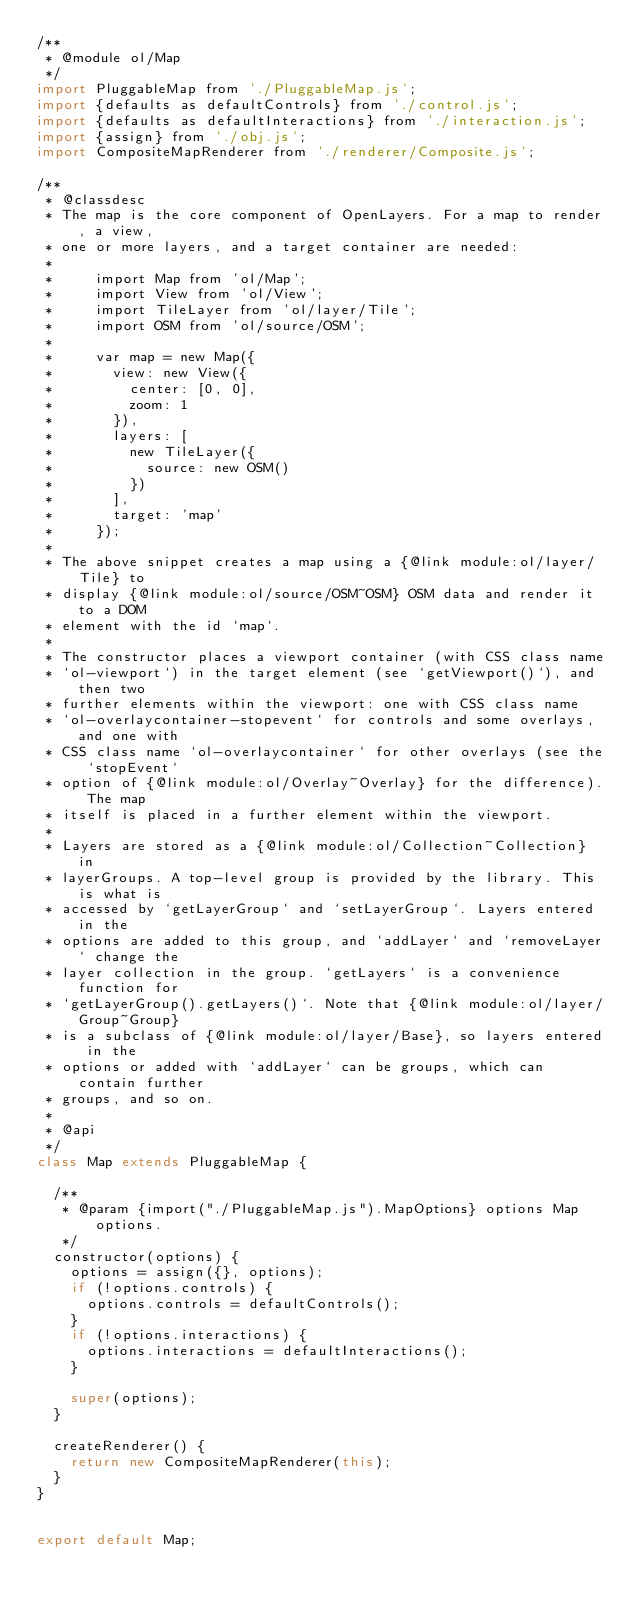Convert code to text. <code><loc_0><loc_0><loc_500><loc_500><_JavaScript_>/**
 * @module ol/Map
 */
import PluggableMap from './PluggableMap.js';
import {defaults as defaultControls} from './control.js';
import {defaults as defaultInteractions} from './interaction.js';
import {assign} from './obj.js';
import CompositeMapRenderer from './renderer/Composite.js';

/**
 * @classdesc
 * The map is the core component of OpenLayers. For a map to render, a view,
 * one or more layers, and a target container are needed:
 *
 *     import Map from 'ol/Map';
 *     import View from 'ol/View';
 *     import TileLayer from 'ol/layer/Tile';
 *     import OSM from 'ol/source/OSM';
 *
 *     var map = new Map({
 *       view: new View({
 *         center: [0, 0],
 *         zoom: 1
 *       }),
 *       layers: [
 *         new TileLayer({
 *           source: new OSM()
 *         })
 *       ],
 *       target: 'map'
 *     });
 *
 * The above snippet creates a map using a {@link module:ol/layer/Tile} to
 * display {@link module:ol/source/OSM~OSM} OSM data and render it to a DOM
 * element with the id `map`.
 *
 * The constructor places a viewport container (with CSS class name
 * `ol-viewport`) in the target element (see `getViewport()`), and then two
 * further elements within the viewport: one with CSS class name
 * `ol-overlaycontainer-stopevent` for controls and some overlays, and one with
 * CSS class name `ol-overlaycontainer` for other overlays (see the `stopEvent`
 * option of {@link module:ol/Overlay~Overlay} for the difference). The map
 * itself is placed in a further element within the viewport.
 *
 * Layers are stored as a {@link module:ol/Collection~Collection} in
 * layerGroups. A top-level group is provided by the library. This is what is
 * accessed by `getLayerGroup` and `setLayerGroup`. Layers entered in the
 * options are added to this group, and `addLayer` and `removeLayer` change the
 * layer collection in the group. `getLayers` is a convenience function for
 * `getLayerGroup().getLayers()`. Note that {@link module:ol/layer/Group~Group}
 * is a subclass of {@link module:ol/layer/Base}, so layers entered in the
 * options or added with `addLayer` can be groups, which can contain further
 * groups, and so on.
 *
 * @api
 */
class Map extends PluggableMap {

  /**
   * @param {import("./PluggableMap.js").MapOptions} options Map options.
   */
  constructor(options) {
    options = assign({}, options);
    if (!options.controls) {
      options.controls = defaultControls();
    }
    if (!options.interactions) {
      options.interactions = defaultInteractions();
    }

    super(options);
  }

  createRenderer() {
    return new CompositeMapRenderer(this);
  }
}


export default Map;
</code> 